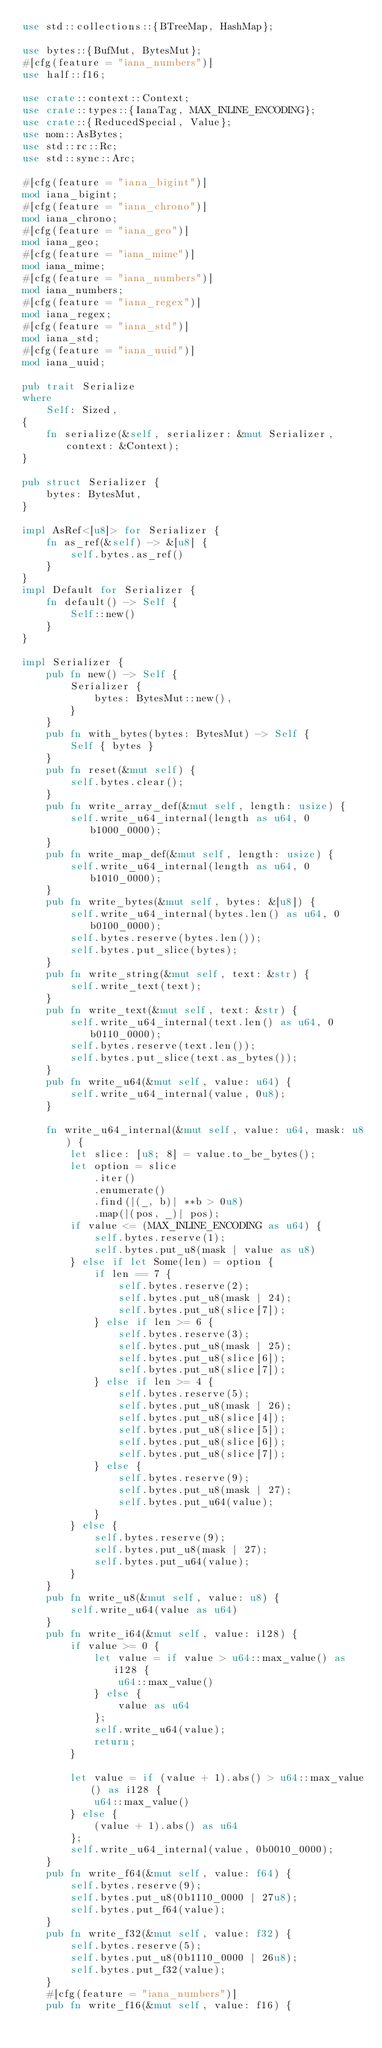Convert code to text. <code><loc_0><loc_0><loc_500><loc_500><_Rust_>use std::collections::{BTreeMap, HashMap};

use bytes::{BufMut, BytesMut};
#[cfg(feature = "iana_numbers")]
use half::f16;

use crate::context::Context;
use crate::types::{IanaTag, MAX_INLINE_ENCODING};
use crate::{ReducedSpecial, Value};
use nom::AsBytes;
use std::rc::Rc;
use std::sync::Arc;

#[cfg(feature = "iana_bigint")]
mod iana_bigint;
#[cfg(feature = "iana_chrono")]
mod iana_chrono;
#[cfg(feature = "iana_geo")]
mod iana_geo;
#[cfg(feature = "iana_mime")]
mod iana_mime;
#[cfg(feature = "iana_numbers")]
mod iana_numbers;
#[cfg(feature = "iana_regex")]
mod iana_regex;
#[cfg(feature = "iana_std")]
mod iana_std;
#[cfg(feature = "iana_uuid")]
mod iana_uuid;

pub trait Serialize
where
    Self: Sized,
{
    fn serialize(&self, serializer: &mut Serializer, context: &Context);
}

pub struct Serializer {
    bytes: BytesMut,
}

impl AsRef<[u8]> for Serializer {
    fn as_ref(&self) -> &[u8] {
        self.bytes.as_ref()
    }
}
impl Default for Serializer {
    fn default() -> Self {
        Self::new()
    }
}

impl Serializer {
    pub fn new() -> Self {
        Serializer {
            bytes: BytesMut::new(),
        }
    }
    pub fn with_bytes(bytes: BytesMut) -> Self {
        Self { bytes }
    }
    pub fn reset(&mut self) {
        self.bytes.clear();
    }
    pub fn write_array_def(&mut self, length: usize) {
        self.write_u64_internal(length as u64, 0b1000_0000);
    }
    pub fn write_map_def(&mut self, length: usize) {
        self.write_u64_internal(length as u64, 0b1010_0000);
    }
    pub fn write_bytes(&mut self, bytes: &[u8]) {
        self.write_u64_internal(bytes.len() as u64, 0b0100_0000);
        self.bytes.reserve(bytes.len());
        self.bytes.put_slice(bytes);
    }
    pub fn write_string(&mut self, text: &str) {
        self.write_text(text);
    }
    pub fn write_text(&mut self, text: &str) {
        self.write_u64_internal(text.len() as u64, 0b0110_0000);
        self.bytes.reserve(text.len());
        self.bytes.put_slice(text.as_bytes());
    }
    pub fn write_u64(&mut self, value: u64) {
        self.write_u64_internal(value, 0u8);
    }

    fn write_u64_internal(&mut self, value: u64, mask: u8) {
        let slice: [u8; 8] = value.to_be_bytes();
        let option = slice
            .iter()
            .enumerate()
            .find(|(_, b)| **b > 0u8)
            .map(|(pos, _)| pos);
        if value <= (MAX_INLINE_ENCODING as u64) {
            self.bytes.reserve(1);
            self.bytes.put_u8(mask | value as u8)
        } else if let Some(len) = option {
            if len == 7 {
                self.bytes.reserve(2);
                self.bytes.put_u8(mask | 24);
                self.bytes.put_u8(slice[7]);
            } else if len >= 6 {
                self.bytes.reserve(3);
                self.bytes.put_u8(mask | 25);
                self.bytes.put_u8(slice[6]);
                self.bytes.put_u8(slice[7]);
            } else if len >= 4 {
                self.bytes.reserve(5);
                self.bytes.put_u8(mask | 26);
                self.bytes.put_u8(slice[4]);
                self.bytes.put_u8(slice[5]);
                self.bytes.put_u8(slice[6]);
                self.bytes.put_u8(slice[7]);
            } else {
                self.bytes.reserve(9);
                self.bytes.put_u8(mask | 27);
                self.bytes.put_u64(value);
            }
        } else {
            self.bytes.reserve(9);
            self.bytes.put_u8(mask | 27);
            self.bytes.put_u64(value);
        }
    }
    pub fn write_u8(&mut self, value: u8) {
        self.write_u64(value as u64)
    }
    pub fn write_i64(&mut self, value: i128) {
        if value >= 0 {
            let value = if value > u64::max_value() as i128 {
                u64::max_value()
            } else {
                value as u64
            };
            self.write_u64(value);
            return;
        }

        let value = if (value + 1).abs() > u64::max_value() as i128 {
            u64::max_value()
        } else {
            (value + 1).abs() as u64
        };
        self.write_u64_internal(value, 0b0010_0000);
    }
    pub fn write_f64(&mut self, value: f64) {
        self.bytes.reserve(9);
        self.bytes.put_u8(0b1110_0000 | 27u8);
        self.bytes.put_f64(value);
    }
    pub fn write_f32(&mut self, value: f32) {
        self.bytes.reserve(5);
        self.bytes.put_u8(0b1110_0000 | 26u8);
        self.bytes.put_f32(value);
    }
    #[cfg(feature = "iana_numbers")]
    pub fn write_f16(&mut self, value: f16) {</code> 